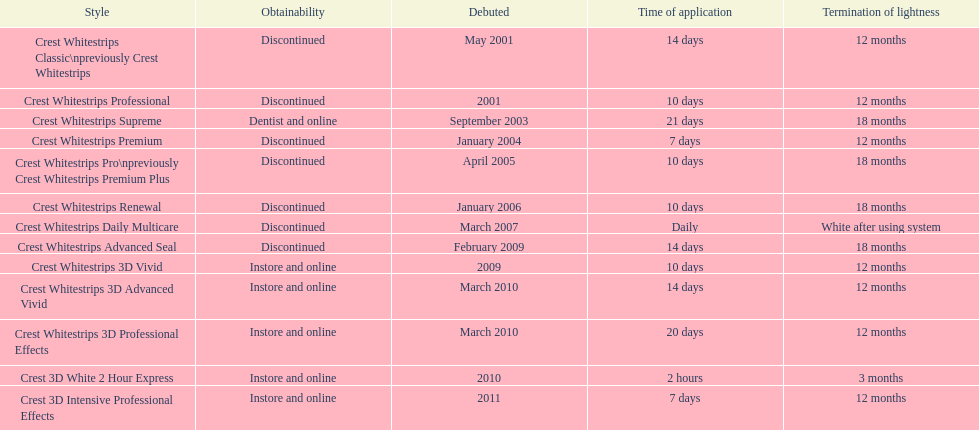Which product was to be used longer, crest whitestrips classic or crest whitestrips 3d vivid? Crest Whitestrips Classic. 